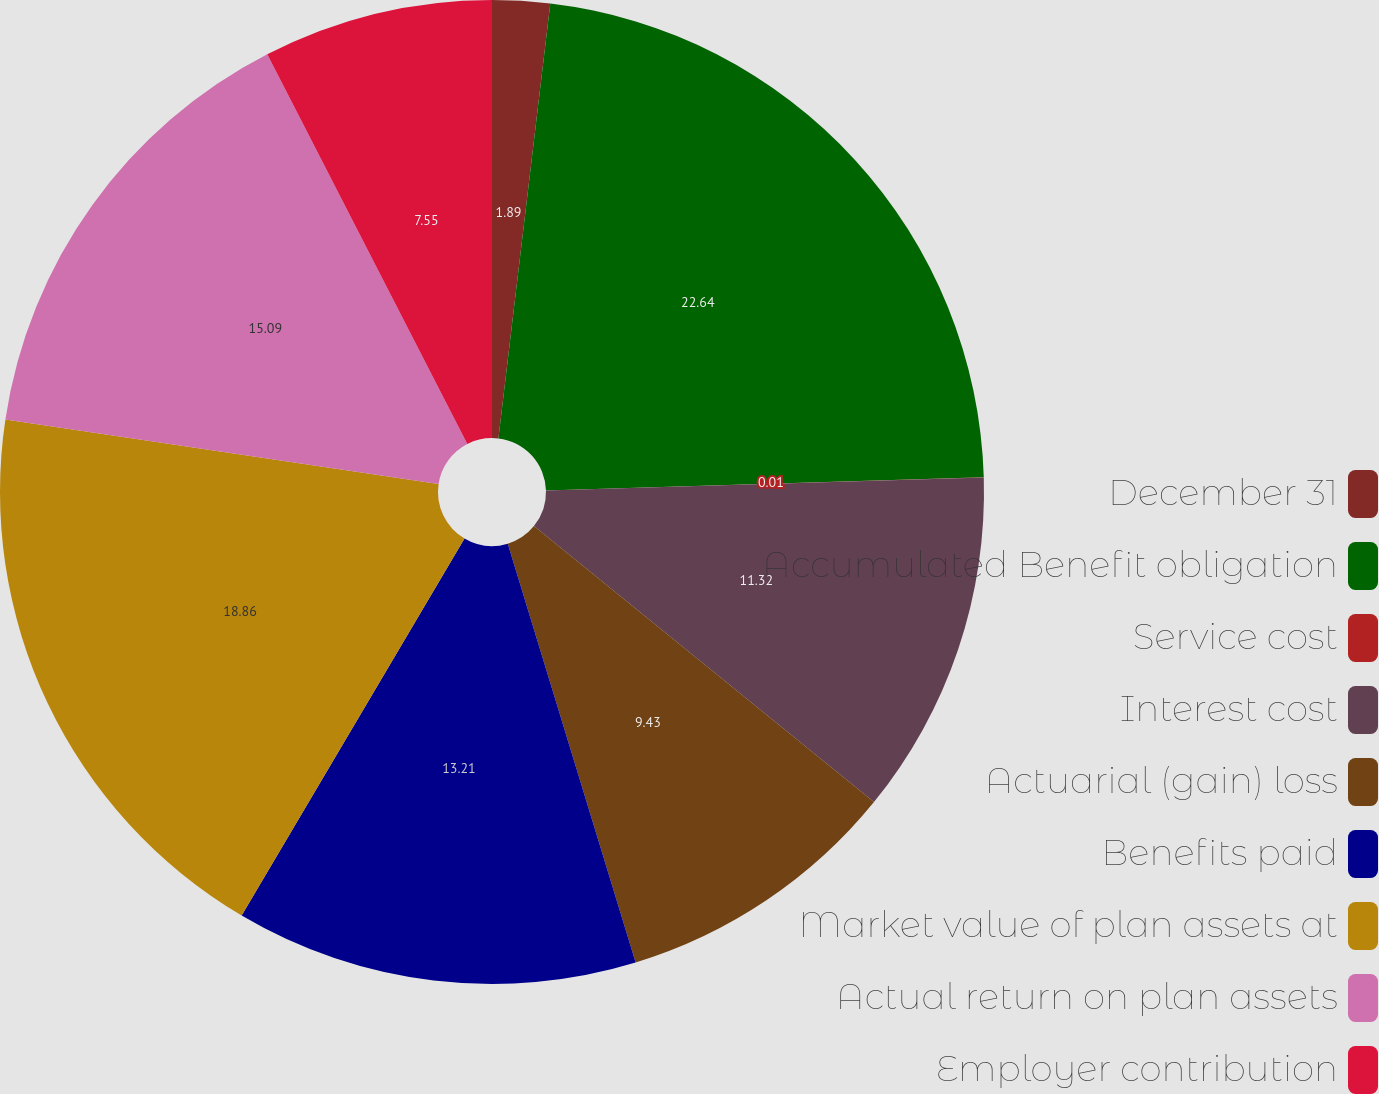Convert chart. <chart><loc_0><loc_0><loc_500><loc_500><pie_chart><fcel>December 31<fcel>Accumulated Benefit obligation<fcel>Service cost<fcel>Interest cost<fcel>Actuarial (gain) loss<fcel>Benefits paid<fcel>Market value of plan assets at<fcel>Actual return on plan assets<fcel>Employer contribution<nl><fcel>1.89%<fcel>22.63%<fcel>0.01%<fcel>11.32%<fcel>9.43%<fcel>13.21%<fcel>18.86%<fcel>15.09%<fcel>7.55%<nl></chart> 